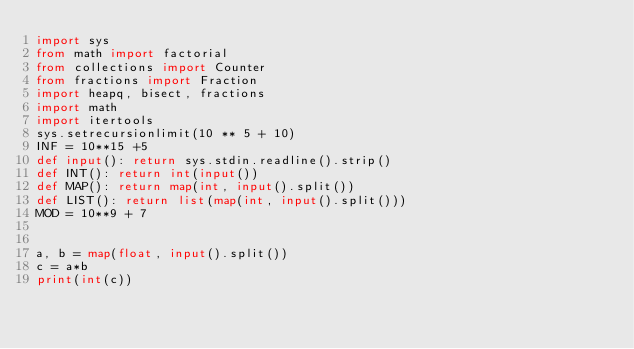<code> <loc_0><loc_0><loc_500><loc_500><_Python_>import sys
from math import factorial
from collections import Counter
from fractions import Fraction
import heapq, bisect, fractions
import math
import itertools
sys.setrecursionlimit(10 ** 5 + 10)
INF = 10**15 +5
def input(): return sys.stdin.readline().strip()
def INT(): return int(input())
def MAP(): return map(int, input().split())
def LIST(): return list(map(int, input().split()))
MOD = 10**9 + 7


a, b = map(float, input().split())
c = a*b
print(int(c))</code> 